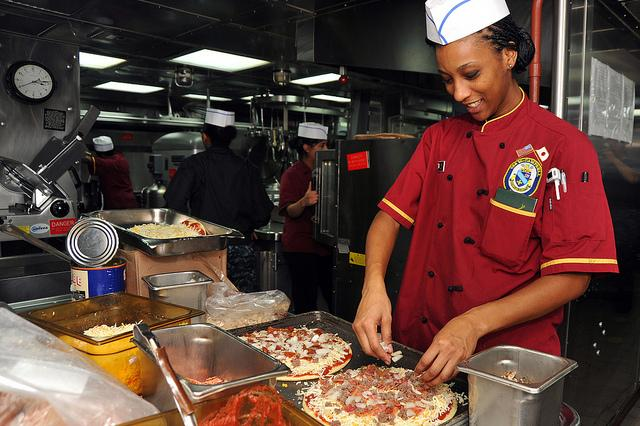What fungus is being added to this pie? mushrooms 